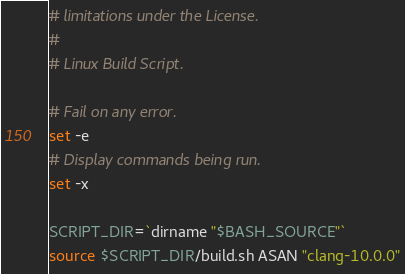Convert code to text. <code><loc_0><loc_0><loc_500><loc_500><_Bash_># limitations under the License.
#
# Linux Build Script.

# Fail on any error.
set -e
# Display commands being run.
set -x

SCRIPT_DIR=`dirname "$BASH_SOURCE"`
source $SCRIPT_DIR/build.sh ASAN "clang-10.0.0"
</code> 